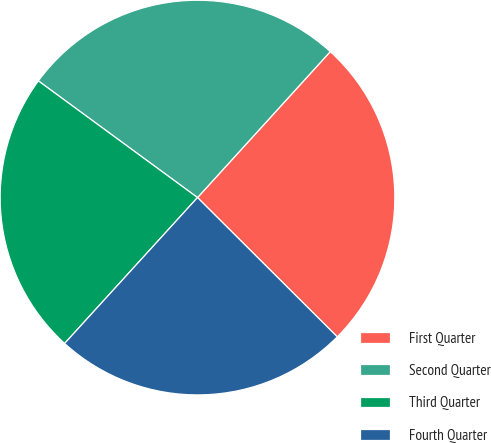<chart> <loc_0><loc_0><loc_500><loc_500><pie_chart><fcel>First Quarter<fcel>Second Quarter<fcel>Third Quarter<fcel>Fourth Quarter<nl><fcel>25.72%<fcel>26.68%<fcel>23.31%<fcel>24.29%<nl></chart> 